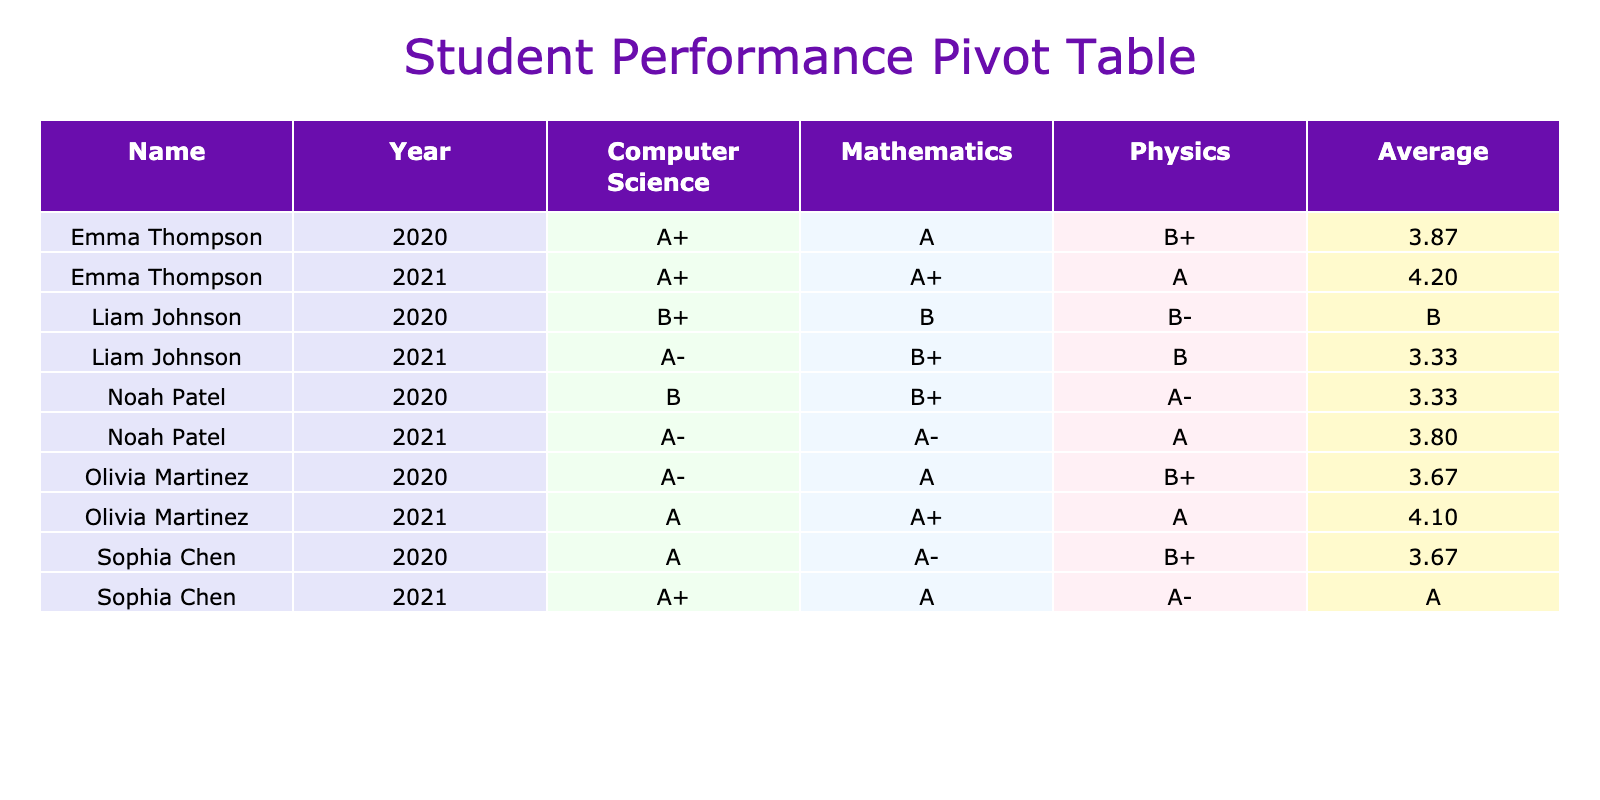What was Liam Johnson's grade in Computer Science for the year 2021? In the table, I look at the row for Liam Johnson under the year 2021 and find the value in the Computer Science column, which is A-.
Answer: A- Which student had the highest average grade across all subjects in 2021? To determine this, I check the average grades in the 2021 section for each student. Emma Thompson has an average of 4.33, Sophia Chen has 4.23, Noah Patel has 4.0, and Olivia Martinez has 4.0. The highest average is Emma Thompson's 4.33.
Answer: Emma Thompson Did Olivia Martinez participate in any extracurricular activities in 2020? I review the rows for Olivia Martinez under the year 2020 and see that she was part of the Math Club. Thus, it is true that she participated in an extracurricular activity that year.
Answer: Yes What is the average grade for Mathematics in 2020, considering only students who studied that subject? The grades for Mathematics in 2020 are A, B, A-, B+, and A. I convert these to numerical values: 4.0, 3.0, 3.7, 3.3, and 4.0. The sum is 18.0 and there are 5 grades, so the average is 18.0 / 5 = 3.6, which corresponds to a B+ grade.
Answer: B+ In which year did Noah Patel improve his grade in Physics from the previous year? I compare Noah Patel's Physics grades from 2020 and 2021. In 2020, he had an A- grade, and in 2021, he achieved an A grade, indicating an improvement. Hence, he improved in 2021 compared to 2020.
Answer: Yes 